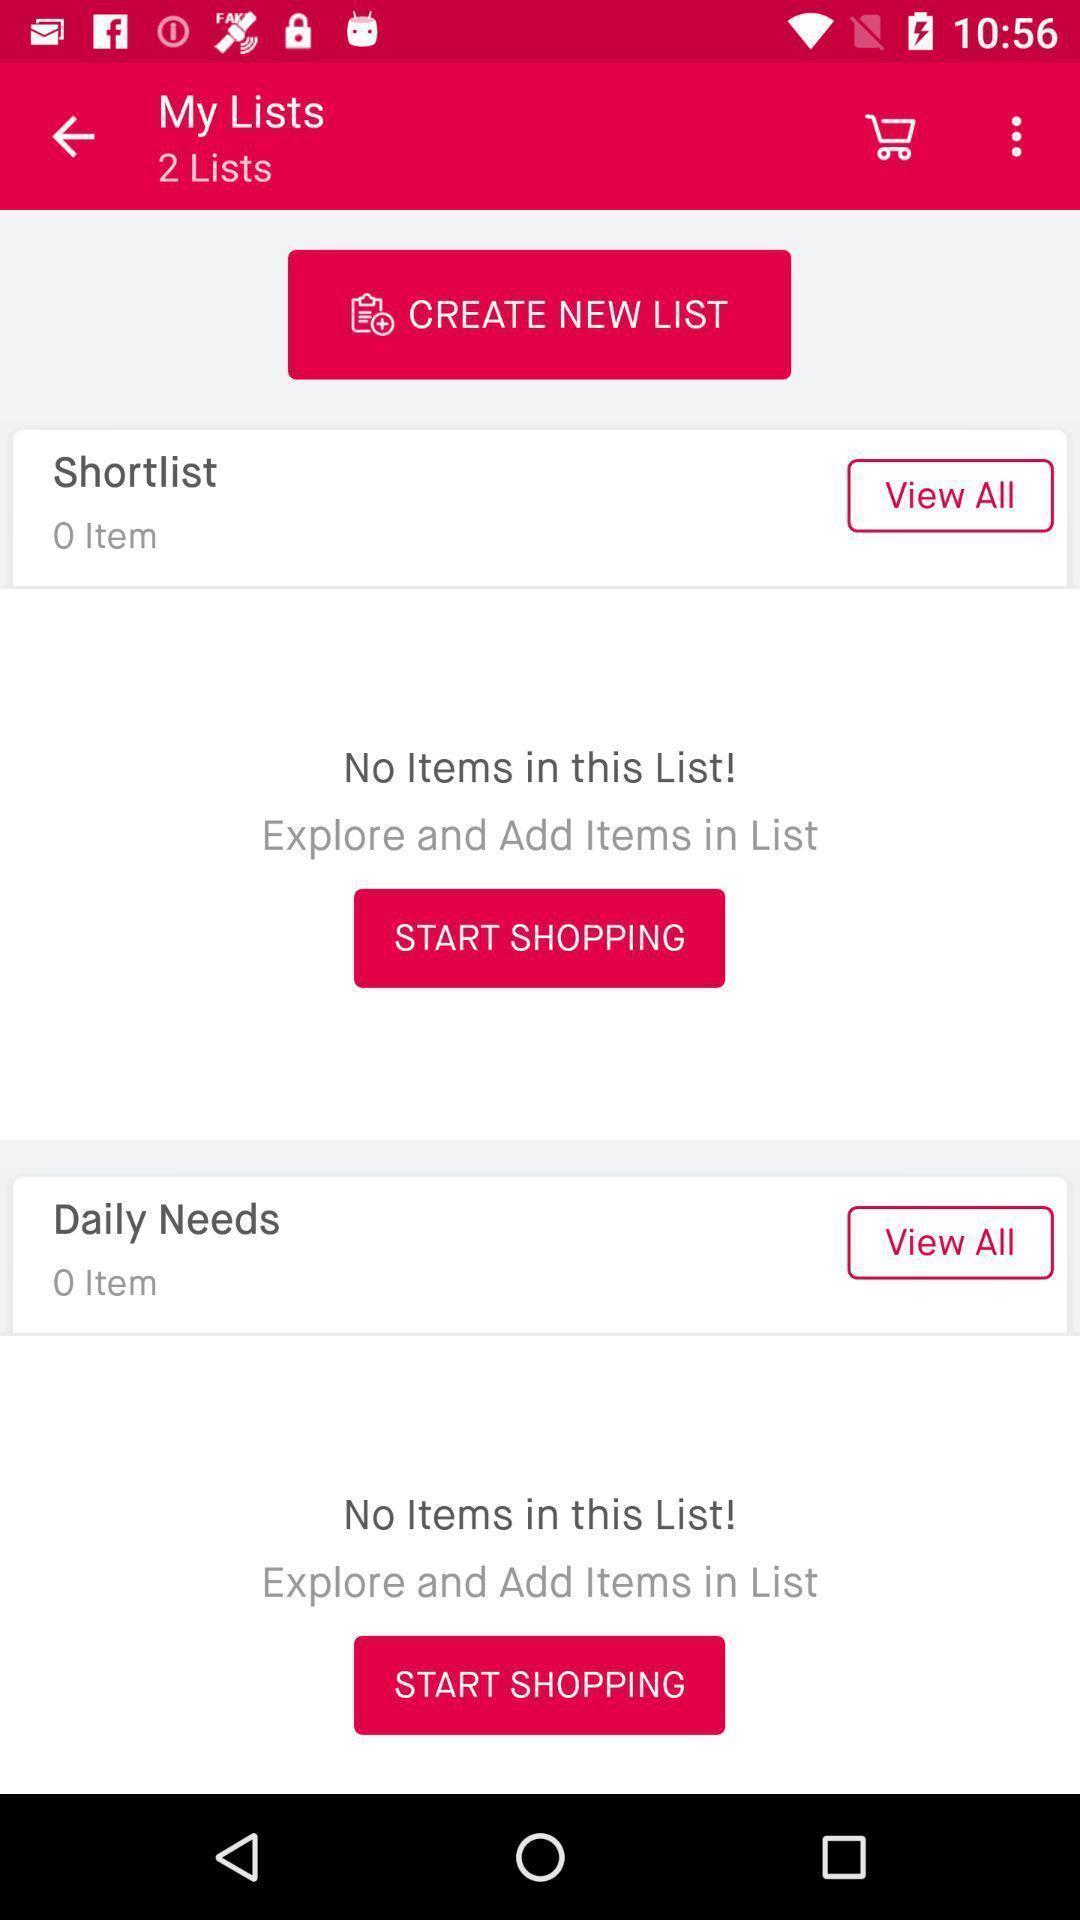Provide a detailed account of this screenshot. Page showing list in shopping app. 